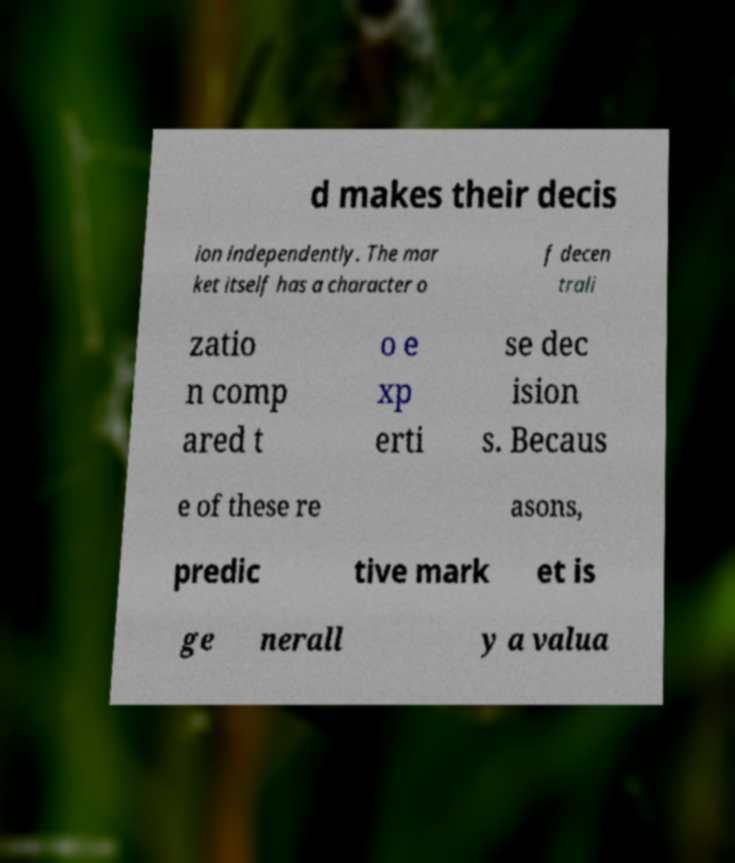Can you read and provide the text displayed in the image?This photo seems to have some interesting text. Can you extract and type it out for me? d makes their decis ion independently. The mar ket itself has a character o f decen trali zatio n comp ared t o e xp erti se dec ision s. Becaus e of these re asons, predic tive mark et is ge nerall y a valua 